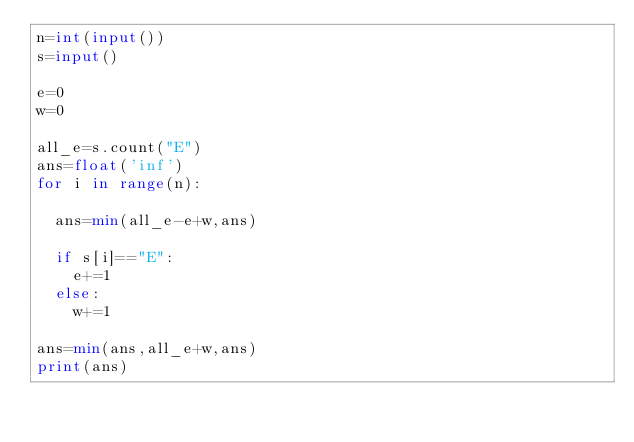<code> <loc_0><loc_0><loc_500><loc_500><_Python_>n=int(input())
s=input()

e=0
w=0

all_e=s.count("E")
ans=float('inf')
for i in range(n):

  ans=min(all_e-e+w,ans)

  if s[i]=="E":
    e+=1
  else:
    w+=1

ans=min(ans,all_e+w,ans)
print(ans)</code> 